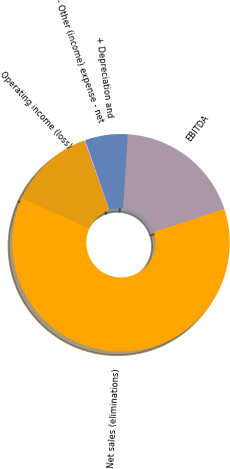Convert chart. <chart><loc_0><loc_0><loc_500><loc_500><pie_chart><fcel>Operating income (loss)<fcel>- Other (income) expense - net<fcel>+ Depreciation and<fcel>EBITDA<fcel>Net sales (eliminations)<nl><fcel>12.76%<fcel>0.17%<fcel>6.33%<fcel>18.92%<fcel>61.82%<nl></chart> 